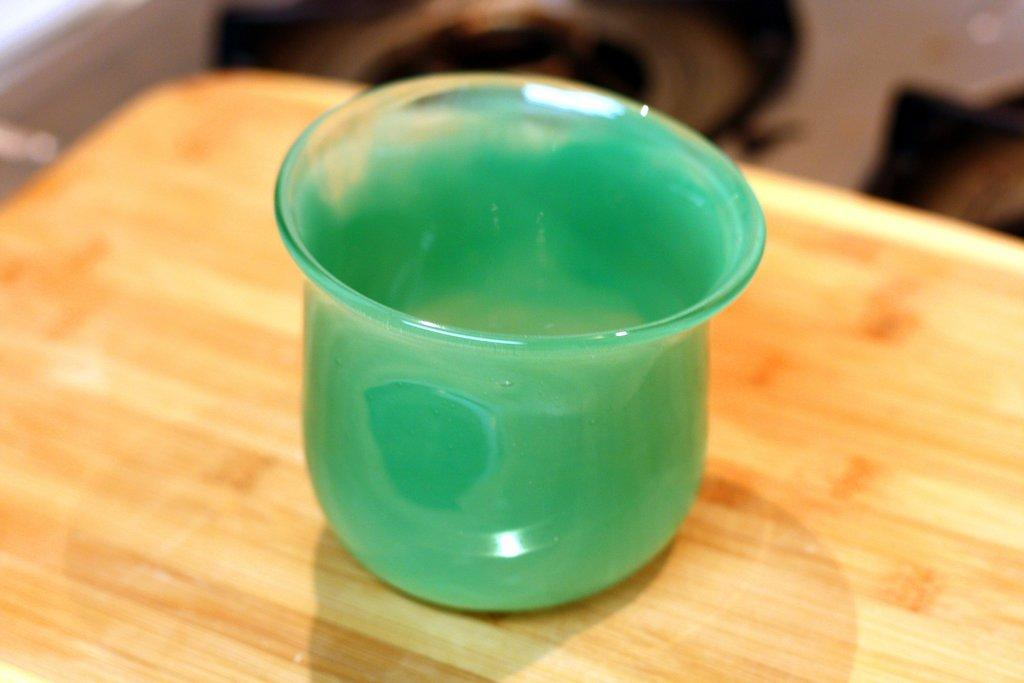What type of object is made of glass in the image? There is a glass item in the picture. Where is the glass item placed? The glass item is on a wooden board. Can you describe the background of the image? The background of the image is blurred. What flavor of ice cream is being served in the glass item in the image? There is no ice cream present in the image, and the glass item's flavor cannot be determined. 